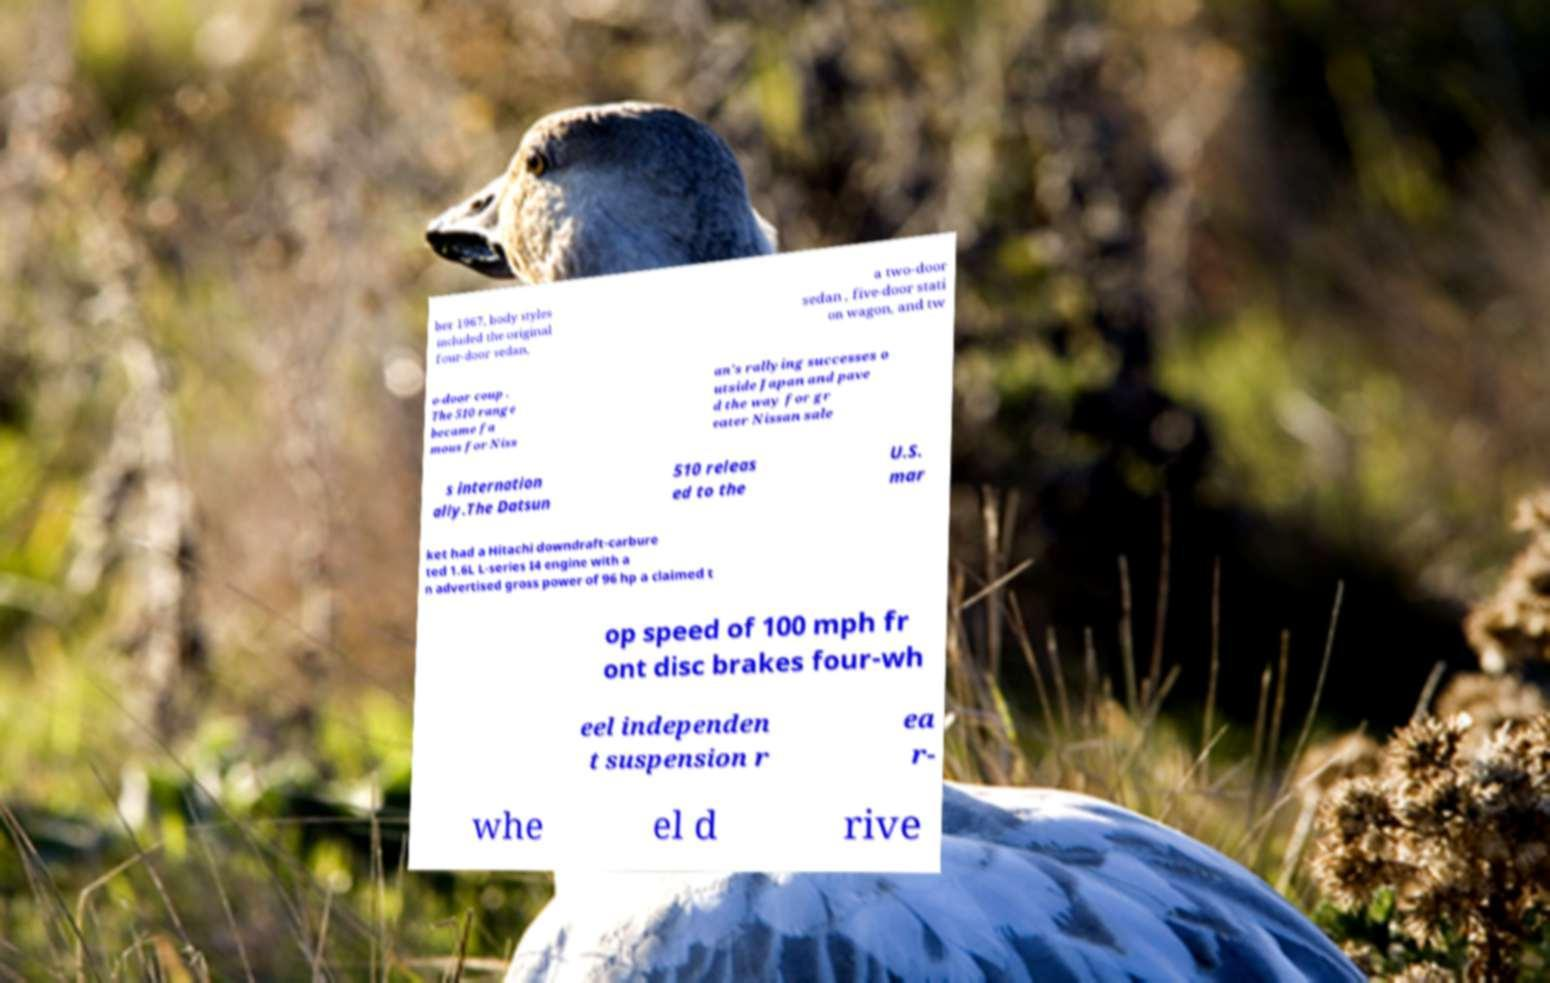Please identify and transcribe the text found in this image. ber 1967, body styles included the original four-door sedan, a two-door sedan , five-door stati on wagon, and tw o-door coup . The 510 range became fa mous for Niss an's rallying successes o utside Japan and pave d the way for gr eater Nissan sale s internation ally.The Datsun 510 releas ed to the U.S. mar ket had a Hitachi downdraft-carbure ted 1.6L L-series I4 engine with a n advertised gross power of 96 hp a claimed t op speed of 100 mph fr ont disc brakes four-wh eel independen t suspension r ea r- whe el d rive 